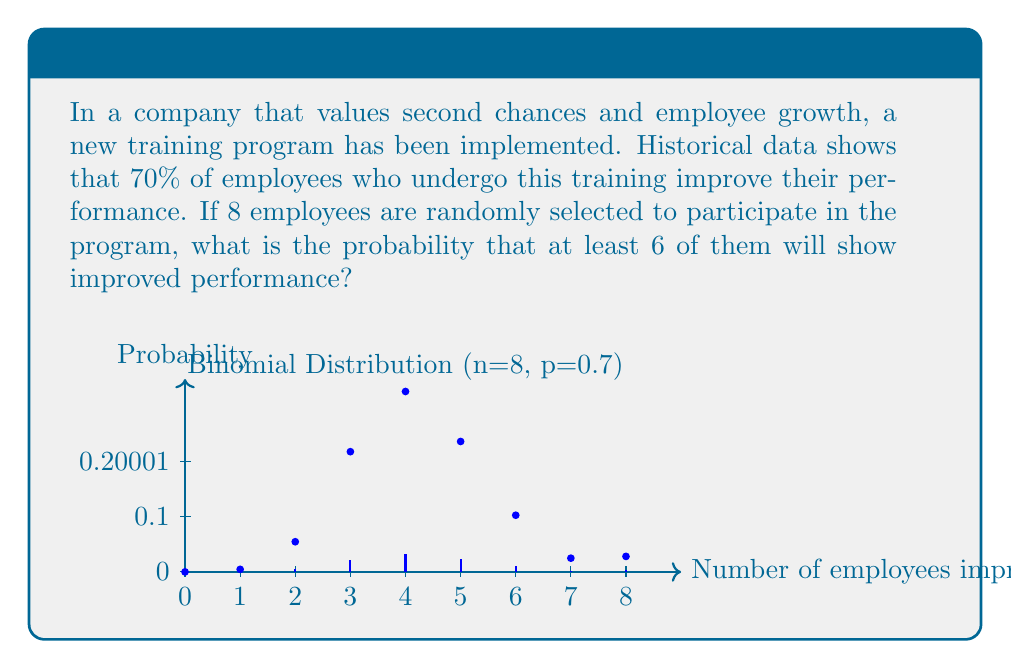Can you solve this math problem? To solve this problem, we'll use the binomial distribution:

1) We have $n = 8$ trials (employees), probability of success $p = 0.7$, and we want at least $k = 6$ successes.

2) The probability of at least 6 successes is the sum of probabilities for 6, 7, and 8 successes:

   $P(X \geq 6) = P(X = 6) + P(X = 7) + P(X = 8)$

3) For each case, we use the binomial probability formula:

   $P(X = k) = \binom{n}{k} p^k (1-p)^{n-k}$

4) Calculating each probability:

   $P(X = 6) = \binom{8}{6} (0.7)^6 (0.3)^2 = 28 \times 0.117649 \times 0.09 = 0.2966$
   
   $P(X = 7) = \binom{8}{7} (0.7)^7 (0.3)^1 = 8 \times 0.082354 \times 0.3 = 0.1977$
   
   $P(X = 8) = \binom{8}{8} (0.7)^8 (0.3)^0 = 1 \times 0.057648 \times 1 = 0.0576$

5) Sum these probabilities:

   $P(X \geq 6) = 0.2966 + 0.1977 + 0.0576 = 0.5519$

Therefore, the probability that at least 6 out of 8 employees will show improved performance is approximately 0.5519 or 55.19%.
Answer: $0.5519$ or $55.19\%$ 